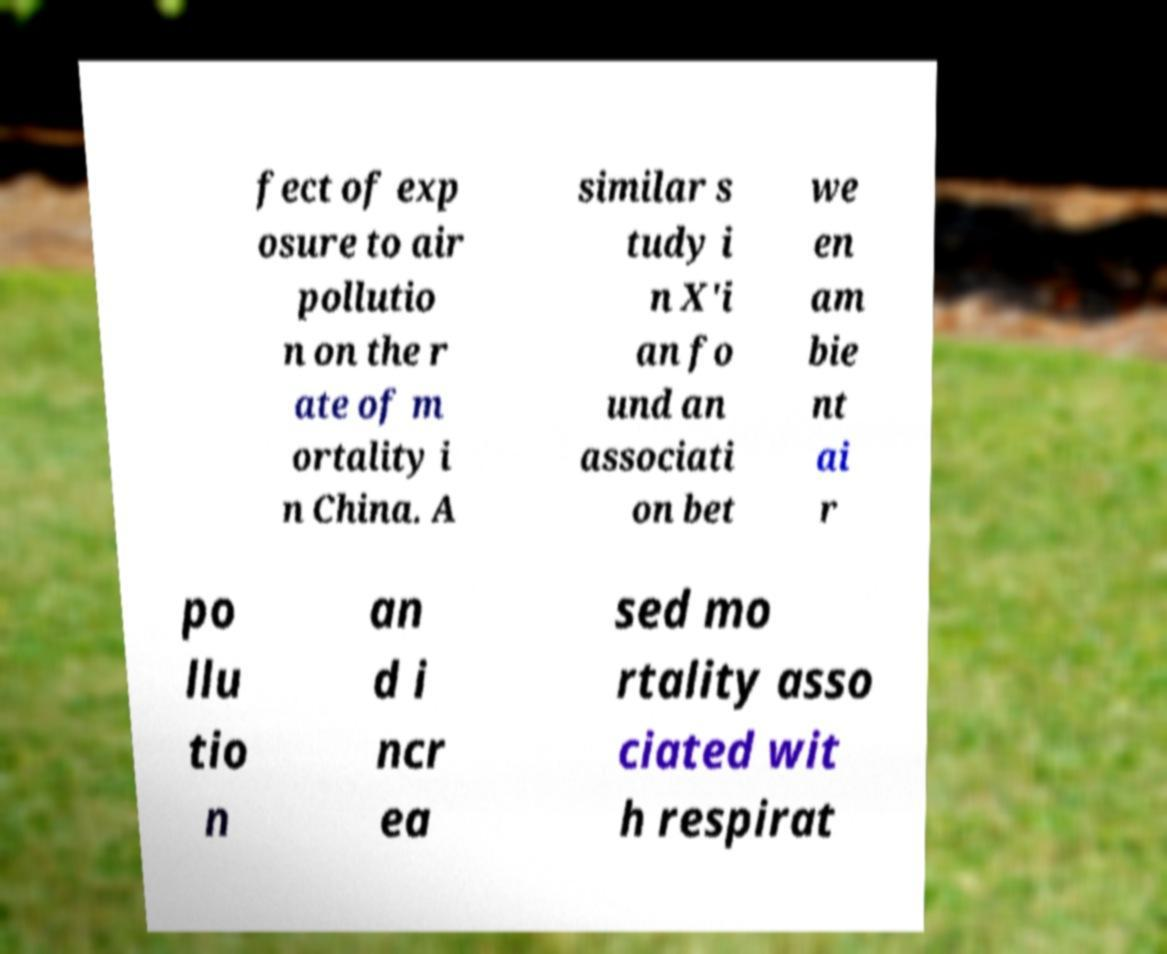Could you assist in decoding the text presented in this image and type it out clearly? fect of exp osure to air pollutio n on the r ate of m ortality i n China. A similar s tudy i n X'i an fo und an associati on bet we en am bie nt ai r po llu tio n an d i ncr ea sed mo rtality asso ciated wit h respirat 